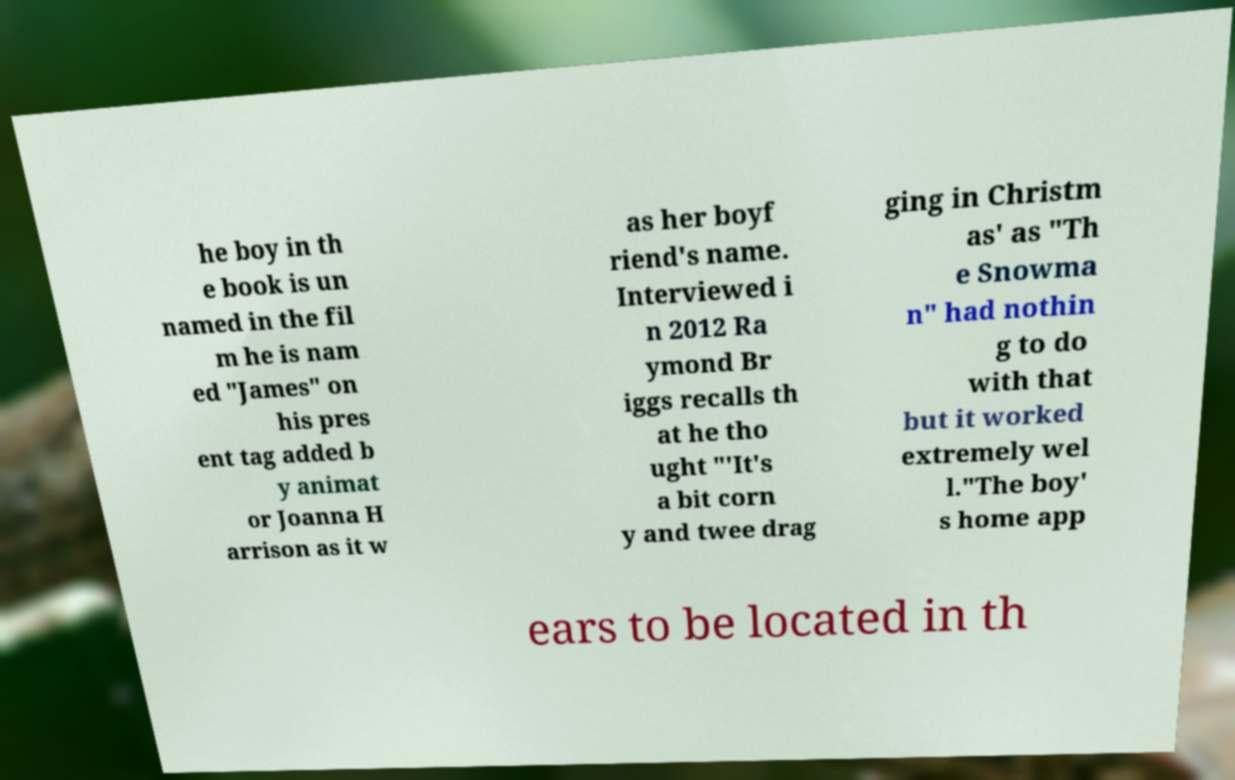Could you assist in decoding the text presented in this image and type it out clearly? he boy in th e book is un named in the fil m he is nam ed "James" on his pres ent tag added b y animat or Joanna H arrison as it w as her boyf riend's name. Interviewed i n 2012 Ra ymond Br iggs recalls th at he tho ught "'It's a bit corn y and twee drag ging in Christm as' as "Th e Snowma n" had nothin g to do with that but it worked extremely wel l."The boy' s home app ears to be located in th 